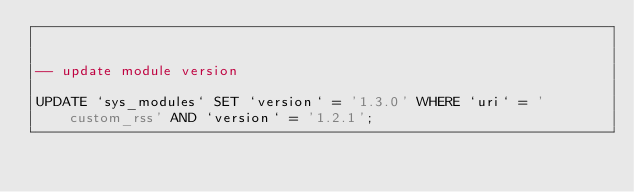<code> <loc_0><loc_0><loc_500><loc_500><_SQL_>

-- update module version

UPDATE `sys_modules` SET `version` = '1.3.0' WHERE `uri` = 'custom_rss' AND `version` = '1.2.1';

</code> 